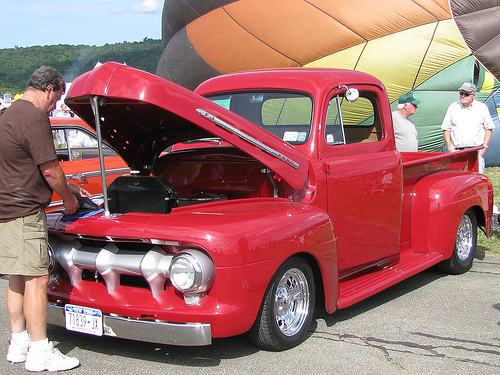<image>
Can you confirm if the man is behind the truck? Yes. From this viewpoint, the man is positioned behind the truck, with the truck partially or fully occluding the man. Is the red truck behind the air balloon? No. The red truck is not behind the air balloon. From this viewpoint, the red truck appears to be positioned elsewhere in the scene. 